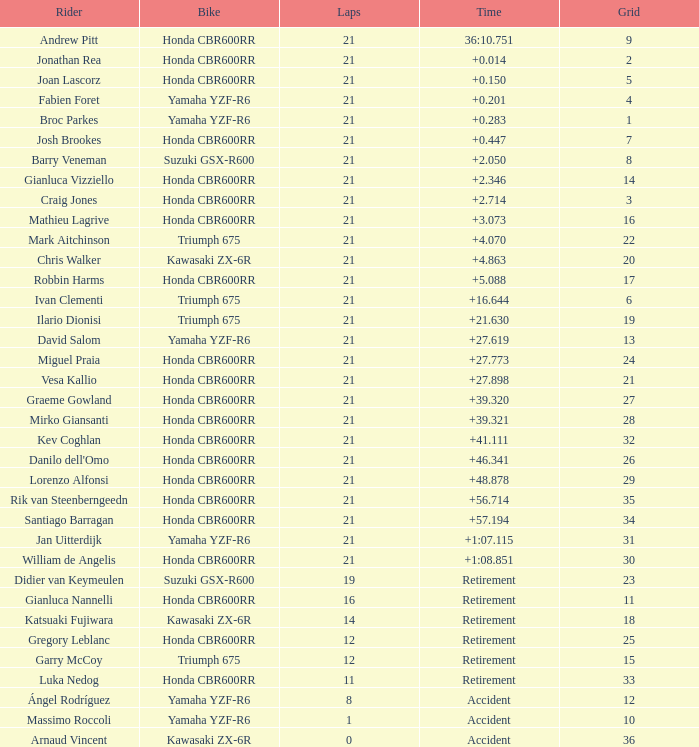What is the driver with the laps under 16, grid of 10, a bike of Yamaha YZF-R6, and ended with an accident? Massimo Roccoli. 